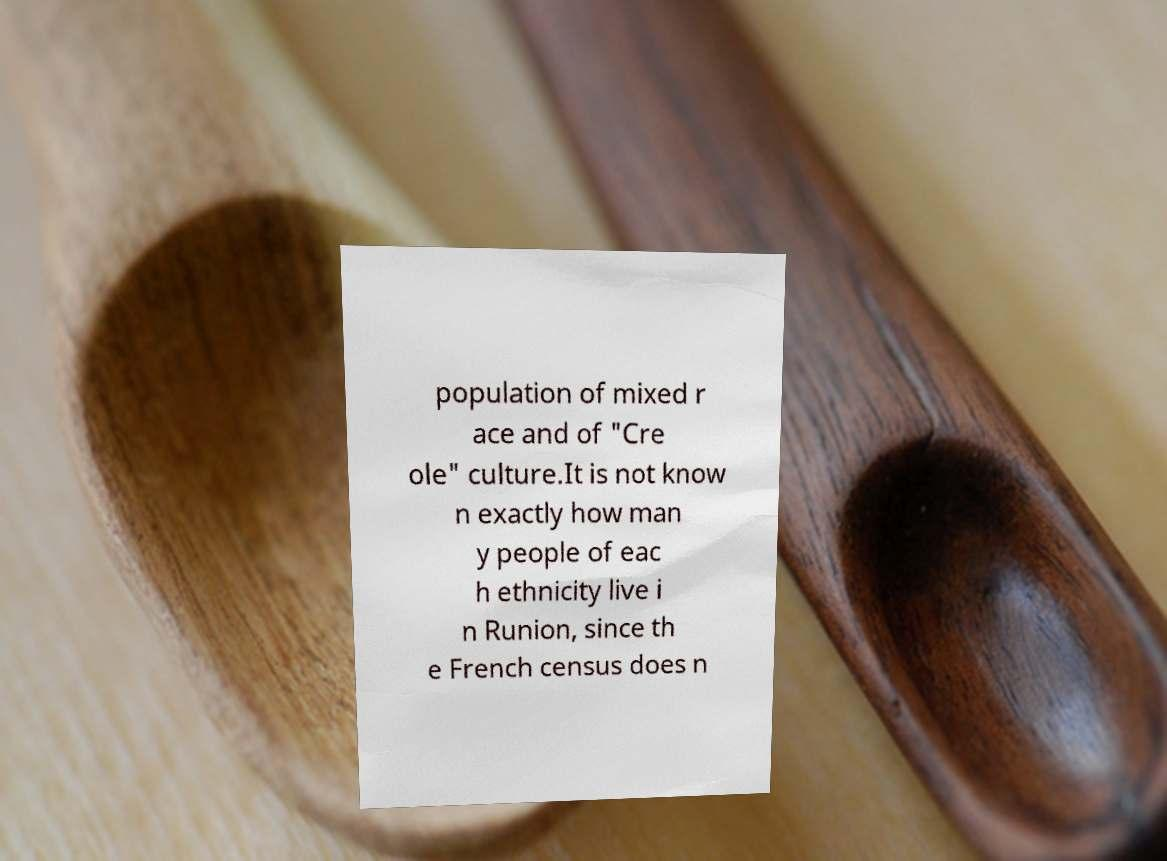Can you accurately transcribe the text from the provided image for me? population of mixed r ace and of "Cre ole" culture.It is not know n exactly how man y people of eac h ethnicity live i n Runion, since th e French census does n 